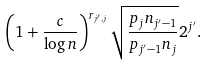Convert formula to latex. <formula><loc_0><loc_0><loc_500><loc_500>\left ( 1 + \frac { c } { \log n } \right ) ^ { r _ { j ^ { \prime } , j } } \sqrt { \frac { p _ { j } n _ { j ^ { \prime } - 1 } } { p _ { j ^ { \prime } - 1 } n _ { j } } } 2 ^ { j ^ { \prime } } .</formula> 